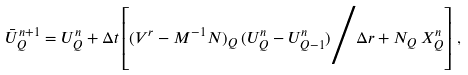<formula> <loc_0><loc_0><loc_500><loc_500>\bar { U } ^ { n + 1 } _ { Q } = U ^ { n } _ { Q } + \Delta t \left [ ( V ^ { r } - M ^ { - 1 } N ) _ { Q } \, ( U ^ { n } _ { Q } - U ^ { n } _ { Q - 1 } ) \Big / \Delta r + N _ { Q } \, X ^ { n } _ { Q } \right ] \, ,</formula> 